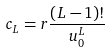<formula> <loc_0><loc_0><loc_500><loc_500>c _ { L } = r \frac { ( L - 1 ) ! } { u _ { 0 } ^ { L } }</formula> 